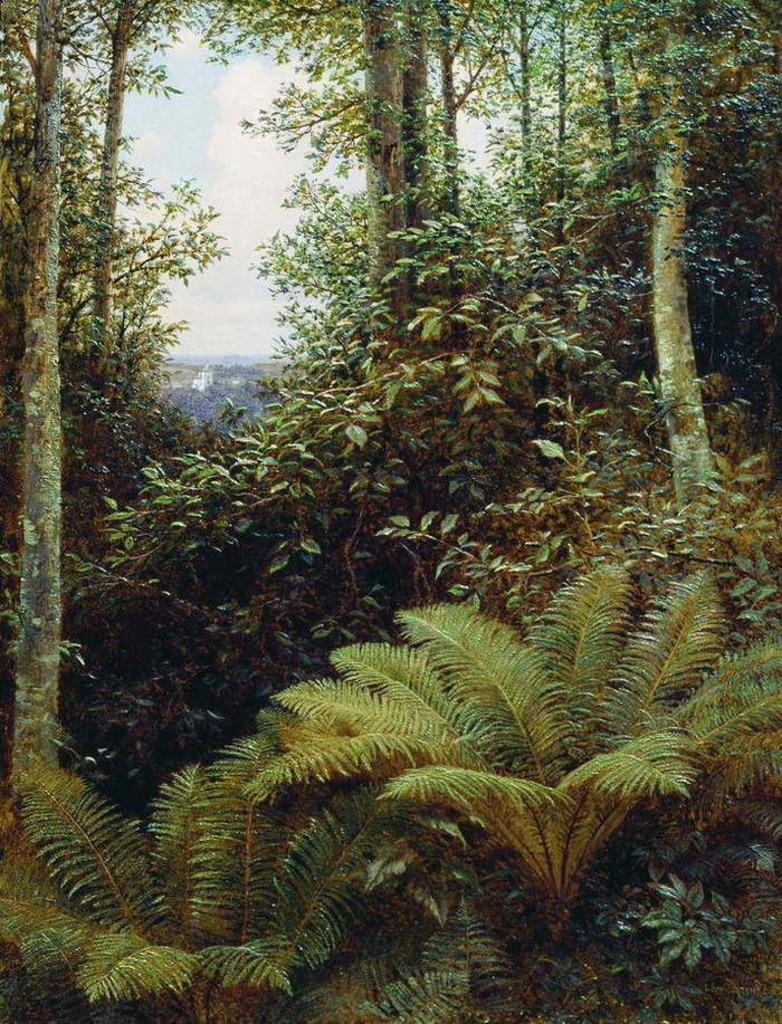What type of vegetation can be seen in the image? There are plants and trees in the image. Where are the plants and trees located? The plants and trees are on land in the image. What can be seen in the sky in the image? There are clouds in the sky in the image. What is the color of the sky in the image? The sky is visible in the image, and it has clouds, but the color is not specified in the facts. What is the annual income of the steel house in the image? There is no steel house or any mention of income in the image. 